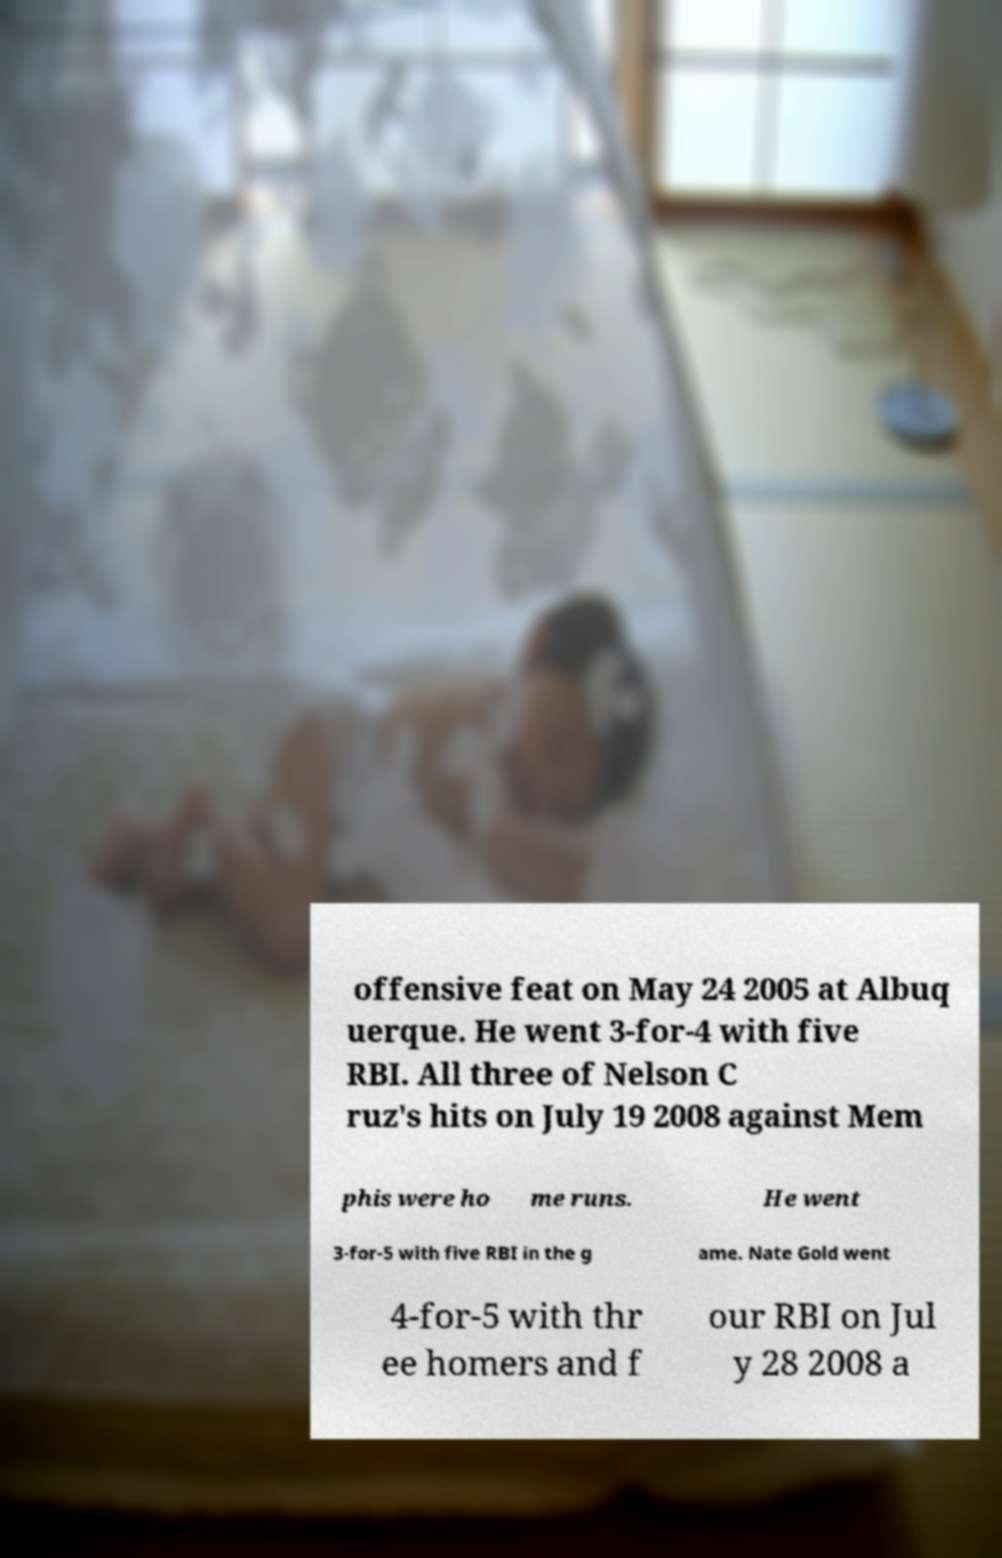I need the written content from this picture converted into text. Can you do that? offensive feat on May 24 2005 at Albuq uerque. He went 3-for-4 with five RBI. All three of Nelson C ruz's hits on July 19 2008 against Mem phis were ho me runs. He went 3-for-5 with five RBI in the g ame. Nate Gold went 4-for-5 with thr ee homers and f our RBI on Jul y 28 2008 a 